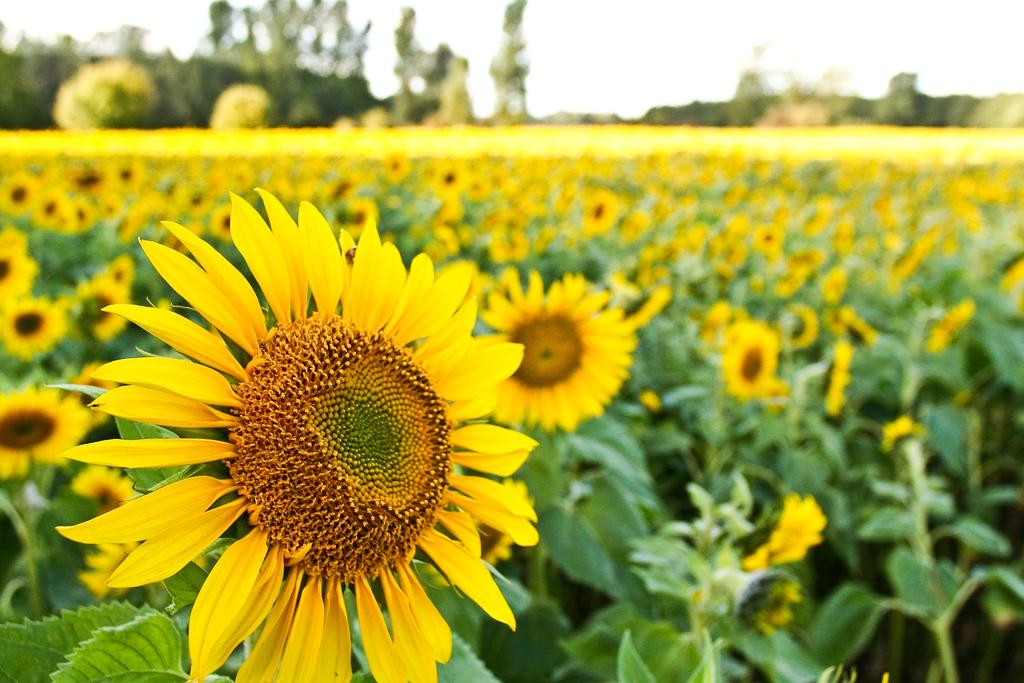What is the main subject of the image? The main subject of the image is a sunflower field. Can you describe the background of the image? The background of the image is blurred. What time does the clock in the image show? There is no clock present in the image. What is the desire of the men in the image? There are no men present in the image. 